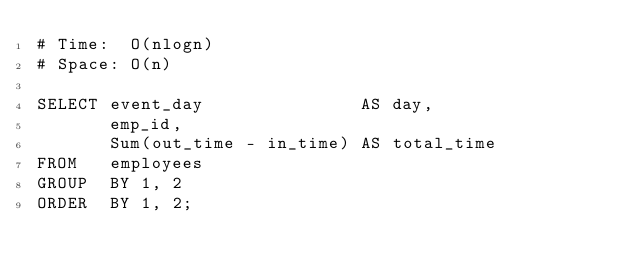<code> <loc_0><loc_0><loc_500><loc_500><_SQL_># Time:  O(nlogn)
# Space: O(n)

SELECT event_day               AS day,
       emp_id,
       Sum(out_time - in_time) AS total_time
FROM   employees
GROUP  BY 1, 2
ORDER  BY 1, 2;
</code> 